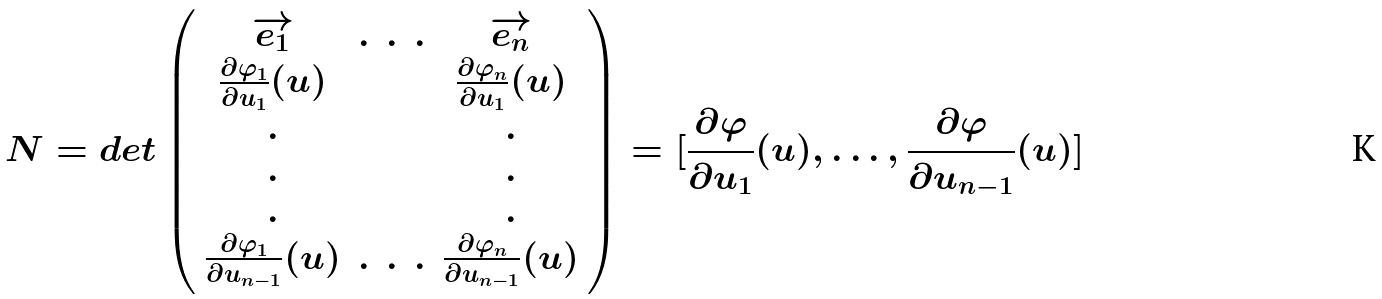Convert formula to latex. <formula><loc_0><loc_0><loc_500><loc_500>N = d e t \left ( \begin{array} { c c c c c } \overrightarrow { e _ { 1 } } & . & . & . & \overrightarrow { e _ { n } } \\ \frac { \partial \varphi _ { 1 } } { \partial u _ { 1 } } ( u ) & & & & \frac { \partial \varphi _ { n } } { \partial u _ { 1 } } ( u ) \\ . & & & & . \\ . & & & & . \\ . & & & & . \\ \frac { \partial \varphi _ { 1 } } { \partial u _ { n - 1 } } ( u ) & . & . & . & \frac { \partial \varphi _ { n } } { \partial u _ { n - 1 } } ( u ) \\ \end{array} \right ) = [ \frac { \partial \varphi } { \partial u _ { 1 } } ( u ) , \dots , \frac { \partial \varphi } { \partial u _ { n - 1 } } ( u ) ]</formula> 